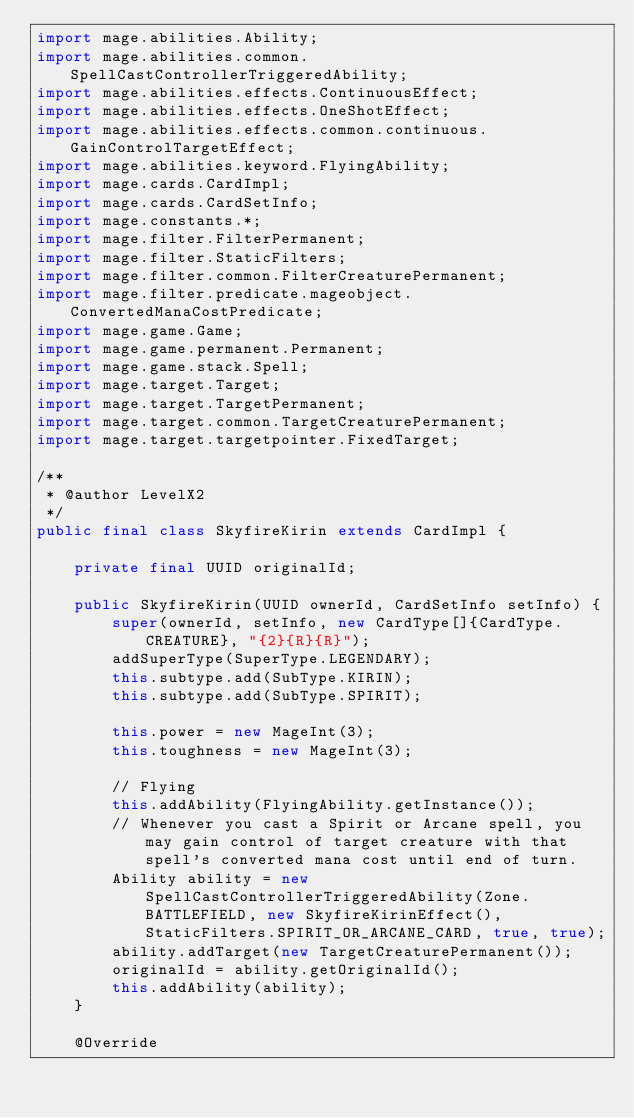<code> <loc_0><loc_0><loc_500><loc_500><_Java_>import mage.abilities.Ability;
import mage.abilities.common.SpellCastControllerTriggeredAbility;
import mage.abilities.effects.ContinuousEffect;
import mage.abilities.effects.OneShotEffect;
import mage.abilities.effects.common.continuous.GainControlTargetEffect;
import mage.abilities.keyword.FlyingAbility;
import mage.cards.CardImpl;
import mage.cards.CardSetInfo;
import mage.constants.*;
import mage.filter.FilterPermanent;
import mage.filter.StaticFilters;
import mage.filter.common.FilterCreaturePermanent;
import mage.filter.predicate.mageobject.ConvertedManaCostPredicate;
import mage.game.Game;
import mage.game.permanent.Permanent;
import mage.game.stack.Spell;
import mage.target.Target;
import mage.target.TargetPermanent;
import mage.target.common.TargetCreaturePermanent;
import mage.target.targetpointer.FixedTarget;

/**
 * @author LevelX2
 */
public final class SkyfireKirin extends CardImpl {

    private final UUID originalId;

    public SkyfireKirin(UUID ownerId, CardSetInfo setInfo) {
        super(ownerId, setInfo, new CardType[]{CardType.CREATURE}, "{2}{R}{R}");
        addSuperType(SuperType.LEGENDARY);
        this.subtype.add(SubType.KIRIN);
        this.subtype.add(SubType.SPIRIT);

        this.power = new MageInt(3);
        this.toughness = new MageInt(3);

        // Flying
        this.addAbility(FlyingAbility.getInstance());
        // Whenever you cast a Spirit or Arcane spell, you may gain control of target creature with that spell's converted mana cost until end of turn.
        Ability ability = new SpellCastControllerTriggeredAbility(Zone.BATTLEFIELD, new SkyfireKirinEffect(), StaticFilters.SPIRIT_OR_ARCANE_CARD, true, true);
        ability.addTarget(new TargetCreaturePermanent());
        originalId = ability.getOriginalId();
        this.addAbility(ability);
    }

    @Override</code> 